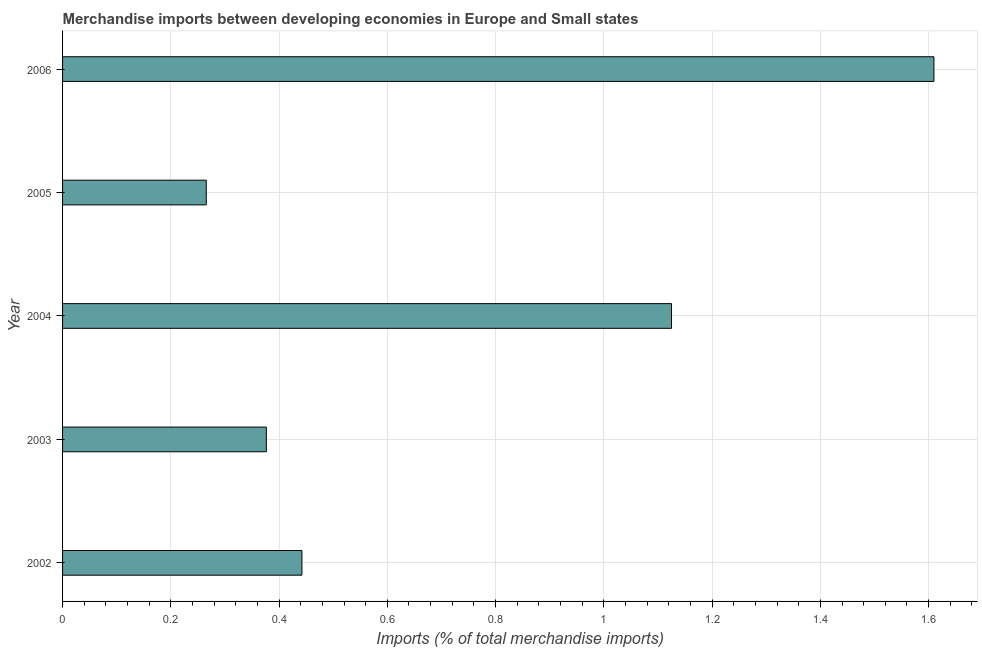What is the title of the graph?
Ensure brevity in your answer.  Merchandise imports between developing economies in Europe and Small states. What is the label or title of the X-axis?
Offer a terse response. Imports (% of total merchandise imports). What is the label or title of the Y-axis?
Offer a very short reply. Year. What is the merchandise imports in 2006?
Offer a very short reply. 1.61. Across all years, what is the maximum merchandise imports?
Your response must be concise. 1.61. Across all years, what is the minimum merchandise imports?
Provide a succinct answer. 0.27. In which year was the merchandise imports minimum?
Provide a short and direct response. 2005. What is the sum of the merchandise imports?
Ensure brevity in your answer.  3.82. What is the difference between the merchandise imports in 2002 and 2005?
Offer a very short reply. 0.18. What is the average merchandise imports per year?
Keep it short and to the point. 0.76. What is the median merchandise imports?
Keep it short and to the point. 0.44. Do a majority of the years between 2002 and 2004 (inclusive) have merchandise imports greater than 0.4 %?
Make the answer very short. Yes. What is the ratio of the merchandise imports in 2005 to that in 2006?
Provide a short and direct response. 0.17. Is the merchandise imports in 2004 less than that in 2005?
Ensure brevity in your answer.  No. What is the difference between the highest and the second highest merchandise imports?
Make the answer very short. 0.48. What is the difference between the highest and the lowest merchandise imports?
Ensure brevity in your answer.  1.34. In how many years, is the merchandise imports greater than the average merchandise imports taken over all years?
Your response must be concise. 2. What is the difference between two consecutive major ticks on the X-axis?
Keep it short and to the point. 0.2. What is the Imports (% of total merchandise imports) in 2002?
Ensure brevity in your answer.  0.44. What is the Imports (% of total merchandise imports) of 2003?
Ensure brevity in your answer.  0.38. What is the Imports (% of total merchandise imports) in 2004?
Your answer should be very brief. 1.13. What is the Imports (% of total merchandise imports) of 2005?
Give a very brief answer. 0.27. What is the Imports (% of total merchandise imports) of 2006?
Make the answer very short. 1.61. What is the difference between the Imports (% of total merchandise imports) in 2002 and 2003?
Give a very brief answer. 0.07. What is the difference between the Imports (% of total merchandise imports) in 2002 and 2004?
Keep it short and to the point. -0.68. What is the difference between the Imports (% of total merchandise imports) in 2002 and 2005?
Provide a succinct answer. 0.18. What is the difference between the Imports (% of total merchandise imports) in 2002 and 2006?
Provide a succinct answer. -1.17. What is the difference between the Imports (% of total merchandise imports) in 2003 and 2004?
Give a very brief answer. -0.75. What is the difference between the Imports (% of total merchandise imports) in 2003 and 2005?
Provide a succinct answer. 0.11. What is the difference between the Imports (% of total merchandise imports) in 2003 and 2006?
Give a very brief answer. -1.23. What is the difference between the Imports (% of total merchandise imports) in 2004 and 2005?
Your response must be concise. 0.86. What is the difference between the Imports (% of total merchandise imports) in 2004 and 2006?
Offer a terse response. -0.48. What is the difference between the Imports (% of total merchandise imports) in 2005 and 2006?
Your answer should be compact. -1.34. What is the ratio of the Imports (% of total merchandise imports) in 2002 to that in 2003?
Offer a very short reply. 1.18. What is the ratio of the Imports (% of total merchandise imports) in 2002 to that in 2004?
Offer a terse response. 0.39. What is the ratio of the Imports (% of total merchandise imports) in 2002 to that in 2005?
Your answer should be compact. 1.67. What is the ratio of the Imports (% of total merchandise imports) in 2002 to that in 2006?
Your answer should be compact. 0.28. What is the ratio of the Imports (% of total merchandise imports) in 2003 to that in 2004?
Offer a terse response. 0.34. What is the ratio of the Imports (% of total merchandise imports) in 2003 to that in 2005?
Provide a succinct answer. 1.42. What is the ratio of the Imports (% of total merchandise imports) in 2003 to that in 2006?
Make the answer very short. 0.23. What is the ratio of the Imports (% of total merchandise imports) in 2004 to that in 2005?
Provide a succinct answer. 4.24. What is the ratio of the Imports (% of total merchandise imports) in 2004 to that in 2006?
Keep it short and to the point. 0.7. What is the ratio of the Imports (% of total merchandise imports) in 2005 to that in 2006?
Your answer should be very brief. 0.17. 